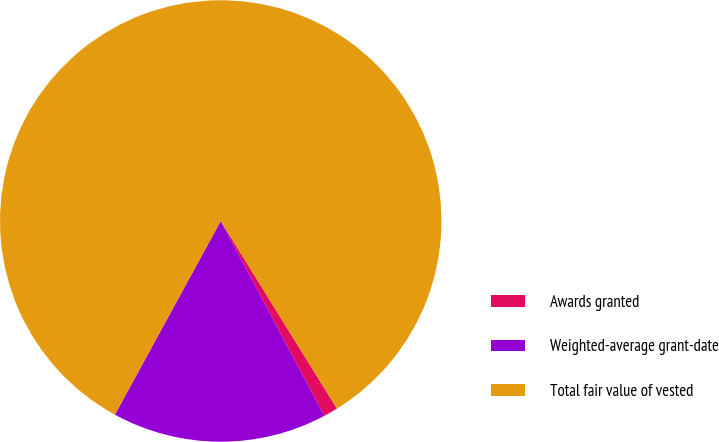<chart> <loc_0><loc_0><loc_500><loc_500><pie_chart><fcel>Awards granted<fcel>Weighted-average grant-date<fcel>Total fair value of vested<nl><fcel>1.05%<fcel>15.74%<fcel>83.2%<nl></chart> 